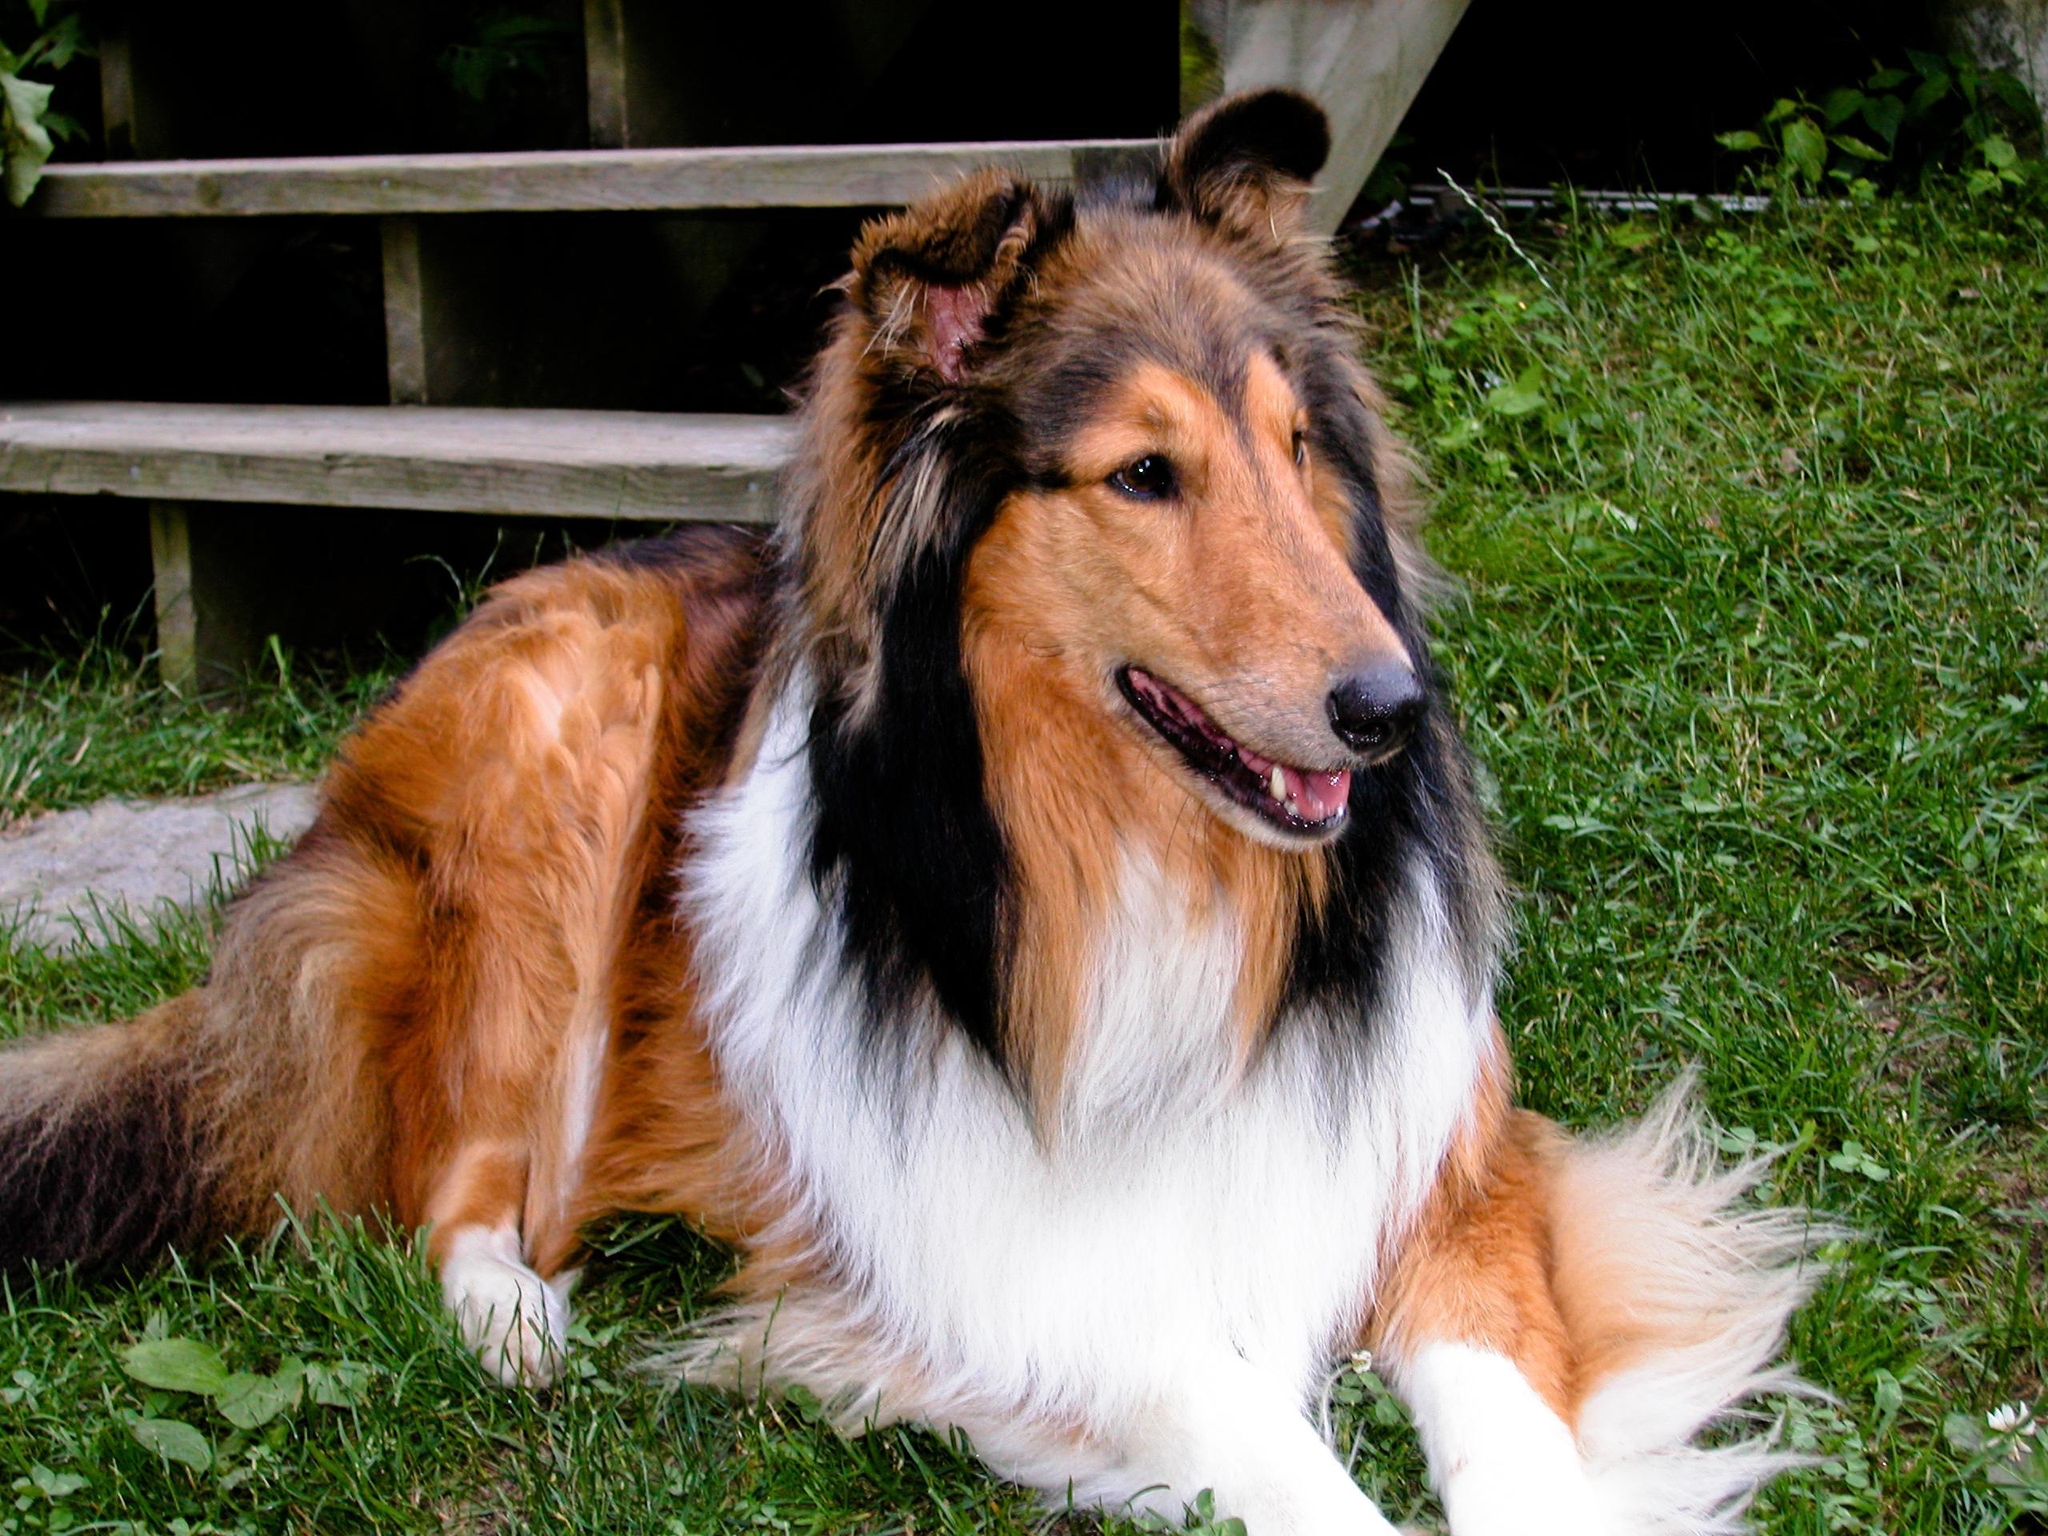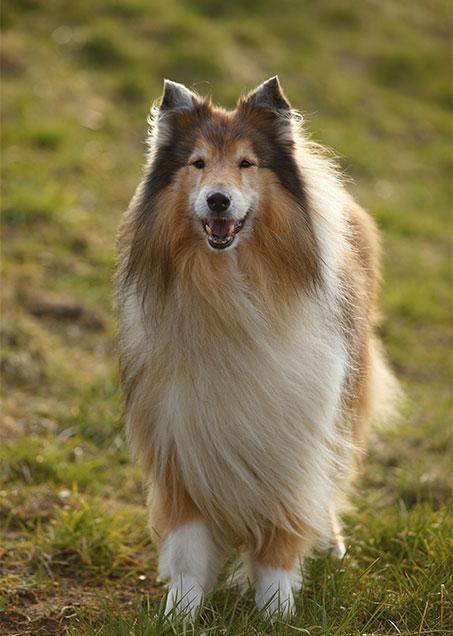The first image is the image on the left, the second image is the image on the right. For the images displayed, is the sentence "An adult collie dog poses in a scene with vibrant flowers." factually correct? Answer yes or no. No. The first image is the image on the left, the second image is the image on the right. Assess this claim about the two images: "One of the dogs is standing in the grass.". Correct or not? Answer yes or no. Yes. 